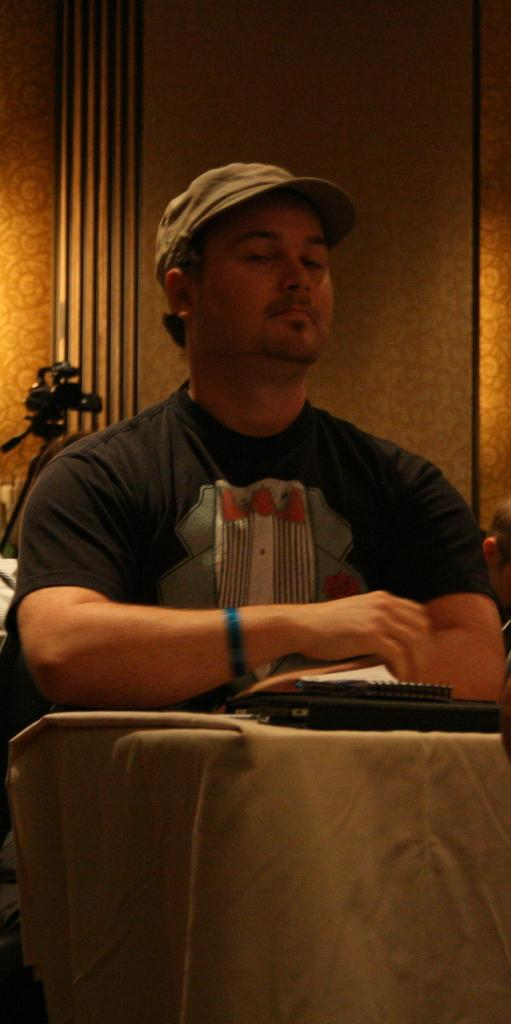What can be seen in the image? There is a person in the image. What is the person wearing on their head? The person is wearing a cap. What objects are in front of the person? There are items in front of the person. What is visible in the background of the image? There is a wall in the background of the image. What piece of equipment is present in the image? There is a video camera on a stand in the image. What type of bird can be seen flying through the door in the image? There is no bird or door present in the image. 